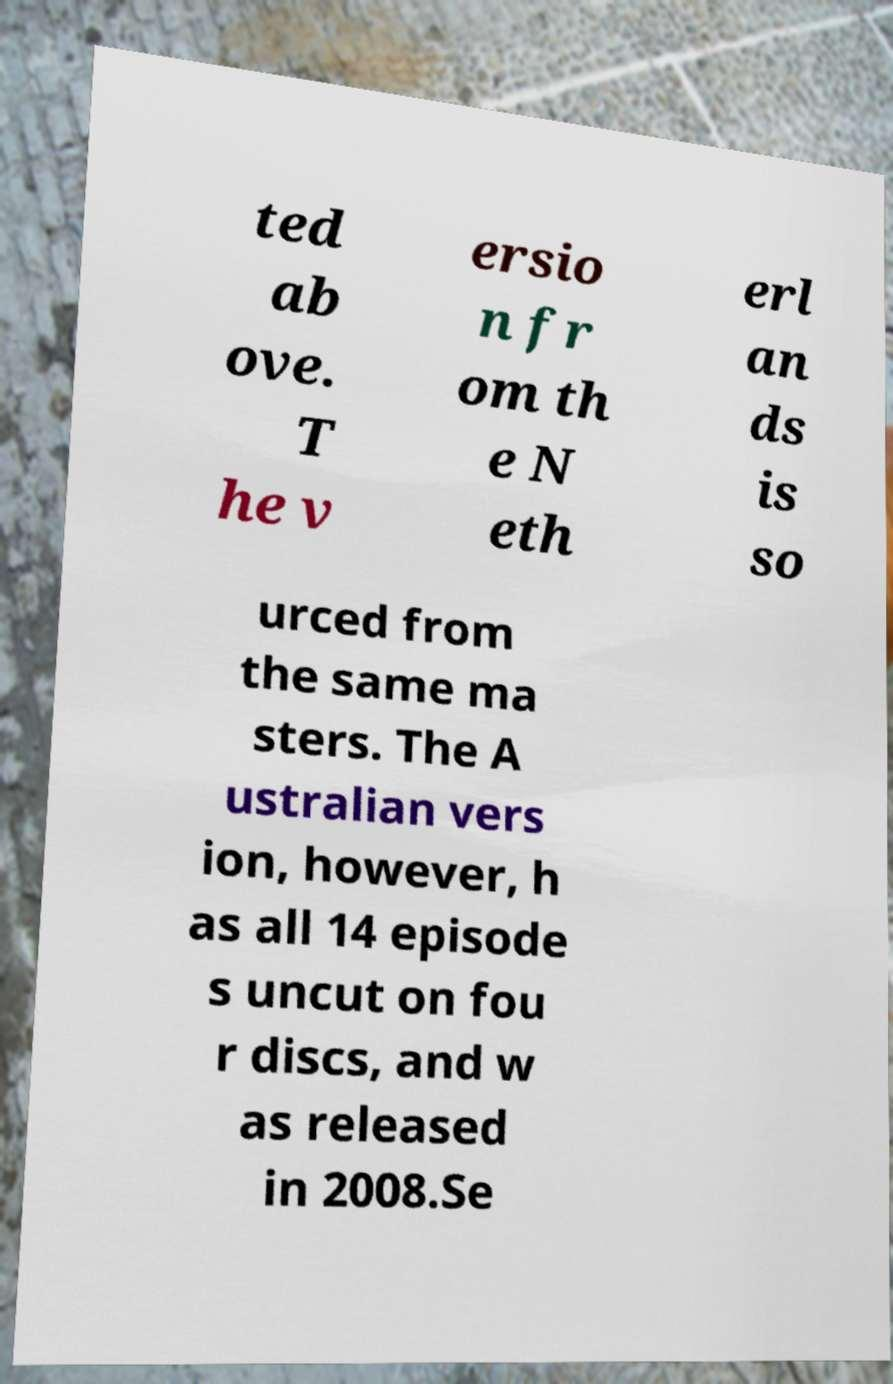Can you accurately transcribe the text from the provided image for me? ted ab ove. T he v ersio n fr om th e N eth erl an ds is so urced from the same ma sters. The A ustralian vers ion, however, h as all 14 episode s uncut on fou r discs, and w as released in 2008.Se 